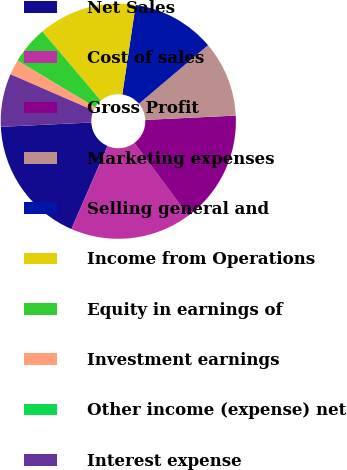<chart> <loc_0><loc_0><loc_500><loc_500><pie_chart><fcel>Net Sales<fcel>Cost of sales<fcel>Gross Profit<fcel>Marketing expenses<fcel>Selling general and<fcel>Income from Operations<fcel>Equity in earnings of<fcel>Investment earnings<fcel>Other income (expense) net<fcel>Interest expense<nl><fcel>17.71%<fcel>16.67%<fcel>15.62%<fcel>10.42%<fcel>11.46%<fcel>13.54%<fcel>5.21%<fcel>2.08%<fcel>0.0%<fcel>7.29%<nl></chart> 